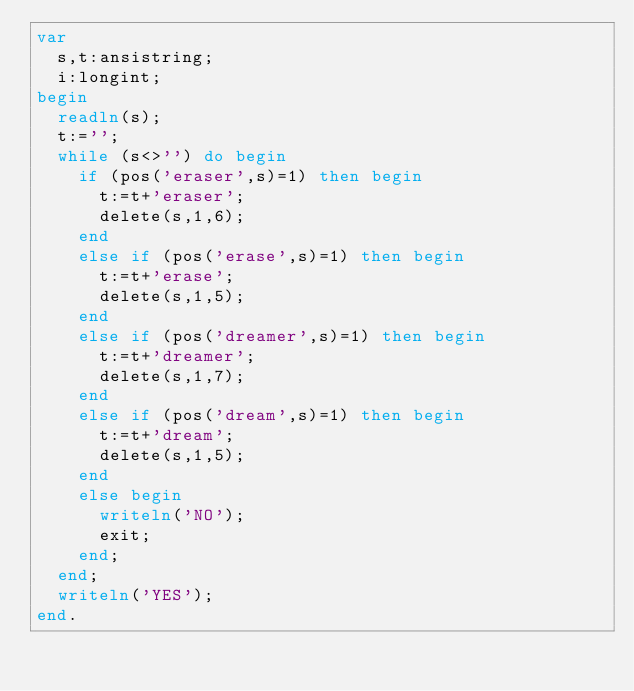<code> <loc_0><loc_0><loc_500><loc_500><_Pascal_>var
  s,t:ansistring;
  i:longint;
begin
  readln(s);
  t:='';
  while (s<>'') do begin
    if (pos('eraser',s)=1) then begin
      t:=t+'eraser';
      delete(s,1,6);
    end
    else if (pos('erase',s)=1) then begin
      t:=t+'erase';
      delete(s,1,5);
    end
    else if (pos('dreamer',s)=1) then begin
      t:=t+'dreamer';
      delete(s,1,7);
    end
    else if (pos('dream',s)=1) then begin
      t:=t+'dream';
      delete(s,1,5);
    end
    else begin
      writeln('NO');
      exit;
    end;
  end;
  writeln('YES');
end.
  </code> 